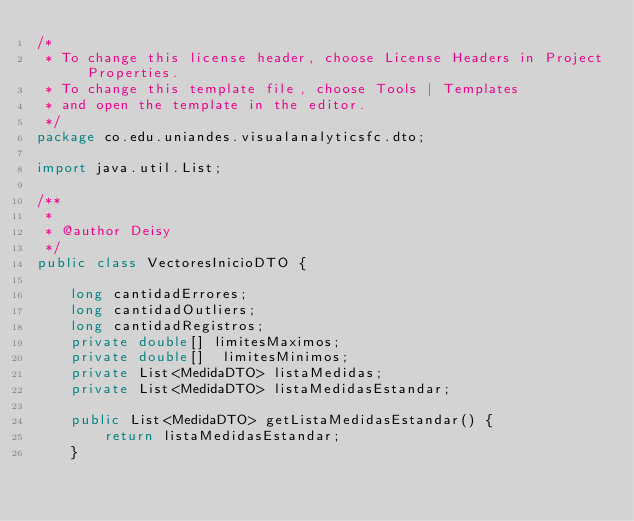Convert code to text. <code><loc_0><loc_0><loc_500><loc_500><_Java_>/*
 * To change this license header, choose License Headers in Project Properties.
 * To change this template file, choose Tools | Templates
 * and open the template in the editor.
 */
package co.edu.uniandes.visualanalyticsfc.dto;

import java.util.List;

/**
 *
 * @author Deisy
 */
public class VectoresInicioDTO {
    
    long cantidadErrores;
    long cantidadOutliers;
    long cantidadRegistros;
    private double[] limitesMaximos;
    private double[]  limitesMinimos;
    private List<MedidaDTO> listaMedidas;
    private List<MedidaDTO> listaMedidasEstandar;

    public List<MedidaDTO> getListaMedidasEstandar() {
        return listaMedidasEstandar;
    }
</code> 